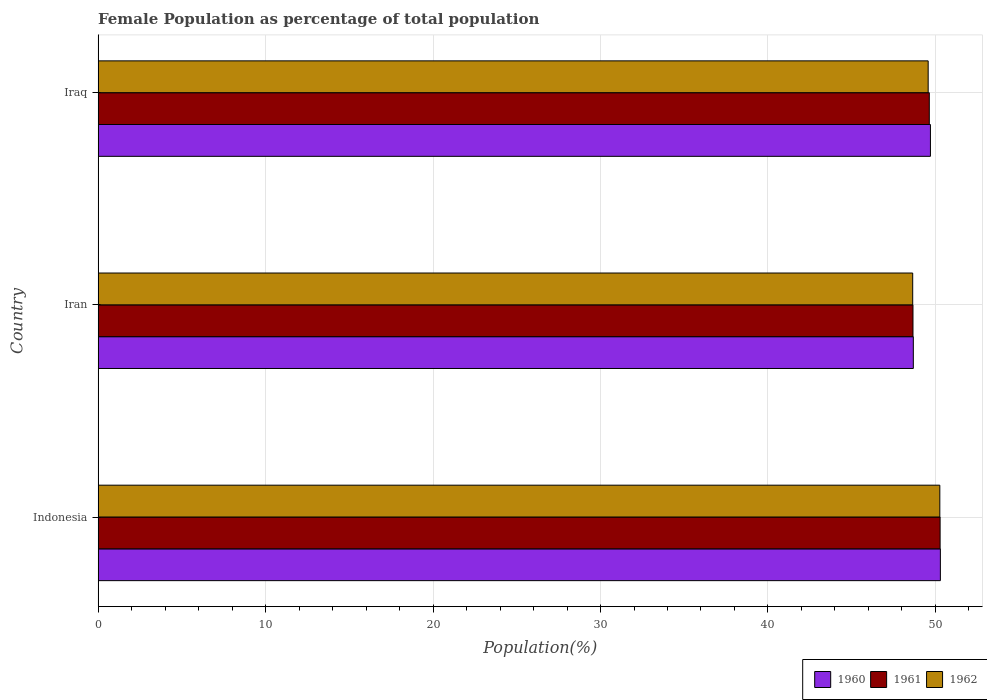How many different coloured bars are there?
Ensure brevity in your answer.  3. How many groups of bars are there?
Provide a succinct answer. 3. How many bars are there on the 1st tick from the bottom?
Make the answer very short. 3. What is the label of the 1st group of bars from the top?
Keep it short and to the point. Iraq. What is the female population in in 1962 in Iran?
Offer a terse response. 48.64. Across all countries, what is the maximum female population in in 1962?
Give a very brief answer. 50.26. Across all countries, what is the minimum female population in in 1962?
Your answer should be very brief. 48.64. In which country was the female population in in 1962 minimum?
Give a very brief answer. Iran. What is the total female population in in 1960 in the graph?
Make the answer very short. 148.68. What is the difference between the female population in in 1962 in Indonesia and that in Iran?
Your answer should be compact. 1.62. What is the difference between the female population in in 1961 in Iraq and the female population in in 1962 in Indonesia?
Your answer should be compact. -0.63. What is the average female population in in 1960 per country?
Make the answer very short. 49.56. What is the difference between the female population in in 1961 and female population in in 1962 in Iran?
Your answer should be compact. 0.02. What is the ratio of the female population in in 1961 in Iran to that in Iraq?
Offer a terse response. 0.98. Is the female population in in 1962 in Indonesia less than that in Iran?
Make the answer very short. No. Is the difference between the female population in in 1961 in Indonesia and Iran greater than the difference between the female population in in 1962 in Indonesia and Iran?
Provide a short and direct response. No. What is the difference between the highest and the second highest female population in in 1962?
Ensure brevity in your answer.  0.7. What is the difference between the highest and the lowest female population in in 1961?
Your answer should be compact. 1.62. Is the sum of the female population in in 1962 in Indonesia and Iran greater than the maximum female population in in 1961 across all countries?
Ensure brevity in your answer.  Yes. What does the 3rd bar from the top in Indonesia represents?
Your response must be concise. 1960. Is it the case that in every country, the sum of the female population in in 1962 and female population in in 1961 is greater than the female population in in 1960?
Offer a very short reply. Yes. Are all the bars in the graph horizontal?
Make the answer very short. Yes. What is the difference between two consecutive major ticks on the X-axis?
Give a very brief answer. 10. Are the values on the major ticks of X-axis written in scientific E-notation?
Offer a terse response. No. Does the graph contain grids?
Offer a very short reply. Yes. What is the title of the graph?
Offer a terse response. Female Population as percentage of total population. What is the label or title of the X-axis?
Keep it short and to the point. Population(%). What is the Population(%) of 1960 in Indonesia?
Provide a short and direct response. 50.3. What is the Population(%) of 1961 in Indonesia?
Offer a very short reply. 50.28. What is the Population(%) of 1962 in Indonesia?
Your answer should be compact. 50.26. What is the Population(%) in 1960 in Iran?
Provide a short and direct response. 48.68. What is the Population(%) in 1961 in Iran?
Offer a terse response. 48.66. What is the Population(%) in 1962 in Iran?
Your response must be concise. 48.64. What is the Population(%) in 1960 in Iraq?
Offer a terse response. 49.7. What is the Population(%) in 1961 in Iraq?
Provide a short and direct response. 49.63. What is the Population(%) of 1962 in Iraq?
Provide a succinct answer. 49.57. Across all countries, what is the maximum Population(%) of 1960?
Ensure brevity in your answer.  50.3. Across all countries, what is the maximum Population(%) of 1961?
Offer a very short reply. 50.28. Across all countries, what is the maximum Population(%) in 1962?
Provide a short and direct response. 50.26. Across all countries, what is the minimum Population(%) in 1960?
Give a very brief answer. 48.68. Across all countries, what is the minimum Population(%) in 1961?
Offer a terse response. 48.66. Across all countries, what is the minimum Population(%) in 1962?
Ensure brevity in your answer.  48.64. What is the total Population(%) of 1960 in the graph?
Your response must be concise. 148.68. What is the total Population(%) in 1961 in the graph?
Offer a very short reply. 148.57. What is the total Population(%) in 1962 in the graph?
Keep it short and to the point. 148.47. What is the difference between the Population(%) of 1960 in Indonesia and that in Iran?
Provide a short and direct response. 1.62. What is the difference between the Population(%) in 1961 in Indonesia and that in Iran?
Your response must be concise. 1.62. What is the difference between the Population(%) of 1962 in Indonesia and that in Iran?
Provide a short and direct response. 1.62. What is the difference between the Population(%) of 1960 in Indonesia and that in Iraq?
Your answer should be very brief. 0.59. What is the difference between the Population(%) of 1961 in Indonesia and that in Iraq?
Provide a short and direct response. 0.65. What is the difference between the Population(%) in 1962 in Indonesia and that in Iraq?
Provide a short and direct response. 0.7. What is the difference between the Population(%) of 1960 in Iran and that in Iraq?
Provide a short and direct response. -1.02. What is the difference between the Population(%) of 1961 in Iran and that in Iraq?
Keep it short and to the point. -0.97. What is the difference between the Population(%) of 1962 in Iran and that in Iraq?
Keep it short and to the point. -0.92. What is the difference between the Population(%) in 1960 in Indonesia and the Population(%) in 1961 in Iran?
Give a very brief answer. 1.64. What is the difference between the Population(%) of 1960 in Indonesia and the Population(%) of 1962 in Iran?
Offer a terse response. 1.65. What is the difference between the Population(%) of 1961 in Indonesia and the Population(%) of 1962 in Iran?
Keep it short and to the point. 1.64. What is the difference between the Population(%) of 1960 in Indonesia and the Population(%) of 1961 in Iraq?
Give a very brief answer. 0.66. What is the difference between the Population(%) of 1960 in Indonesia and the Population(%) of 1962 in Iraq?
Offer a very short reply. 0.73. What is the difference between the Population(%) in 1961 in Indonesia and the Population(%) in 1962 in Iraq?
Your answer should be very brief. 0.71. What is the difference between the Population(%) in 1960 in Iran and the Population(%) in 1961 in Iraq?
Offer a terse response. -0.95. What is the difference between the Population(%) of 1960 in Iran and the Population(%) of 1962 in Iraq?
Ensure brevity in your answer.  -0.89. What is the difference between the Population(%) in 1961 in Iran and the Population(%) in 1962 in Iraq?
Your answer should be compact. -0.91. What is the average Population(%) of 1960 per country?
Make the answer very short. 49.56. What is the average Population(%) in 1961 per country?
Your response must be concise. 49.52. What is the average Population(%) in 1962 per country?
Give a very brief answer. 49.49. What is the difference between the Population(%) of 1960 and Population(%) of 1961 in Indonesia?
Keep it short and to the point. 0.02. What is the difference between the Population(%) in 1960 and Population(%) in 1962 in Indonesia?
Ensure brevity in your answer.  0.03. What is the difference between the Population(%) of 1961 and Population(%) of 1962 in Indonesia?
Your answer should be very brief. 0.02. What is the difference between the Population(%) in 1960 and Population(%) in 1961 in Iran?
Your answer should be compact. 0.02. What is the difference between the Population(%) of 1960 and Population(%) of 1962 in Iran?
Your answer should be very brief. 0.04. What is the difference between the Population(%) in 1961 and Population(%) in 1962 in Iran?
Your response must be concise. 0.02. What is the difference between the Population(%) of 1960 and Population(%) of 1961 in Iraq?
Offer a terse response. 0.07. What is the difference between the Population(%) of 1960 and Population(%) of 1962 in Iraq?
Offer a very short reply. 0.13. What is the difference between the Population(%) in 1961 and Population(%) in 1962 in Iraq?
Your response must be concise. 0.07. What is the ratio of the Population(%) in 1960 in Indonesia to that in Iran?
Your answer should be very brief. 1.03. What is the ratio of the Population(%) in 1960 in Indonesia to that in Iraq?
Provide a succinct answer. 1.01. What is the ratio of the Population(%) in 1961 in Indonesia to that in Iraq?
Your response must be concise. 1.01. What is the ratio of the Population(%) in 1962 in Indonesia to that in Iraq?
Make the answer very short. 1.01. What is the ratio of the Population(%) of 1960 in Iran to that in Iraq?
Give a very brief answer. 0.98. What is the ratio of the Population(%) of 1961 in Iran to that in Iraq?
Offer a terse response. 0.98. What is the ratio of the Population(%) in 1962 in Iran to that in Iraq?
Your answer should be very brief. 0.98. What is the difference between the highest and the second highest Population(%) in 1960?
Your answer should be very brief. 0.59. What is the difference between the highest and the second highest Population(%) in 1961?
Give a very brief answer. 0.65. What is the difference between the highest and the second highest Population(%) in 1962?
Make the answer very short. 0.7. What is the difference between the highest and the lowest Population(%) in 1960?
Your answer should be very brief. 1.62. What is the difference between the highest and the lowest Population(%) in 1961?
Offer a very short reply. 1.62. What is the difference between the highest and the lowest Population(%) of 1962?
Your answer should be very brief. 1.62. 